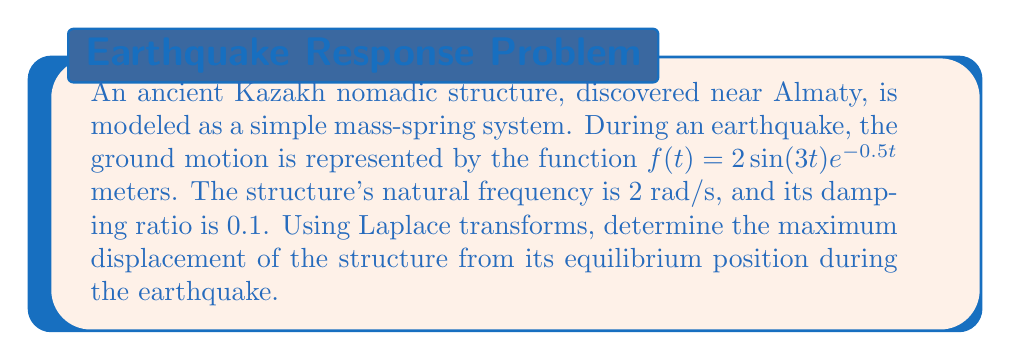Show me your answer to this math problem. Let's approach this step-by-step using Laplace transforms:

1) The equation of motion for a forced, damped harmonic oscillator is:
   $$m\ddot{x} + c\dot{x} + kx = F(t)$$

2) Given information:
   - Natural frequency: $\omega_n = 2$ rad/s
   - Damping ratio: $\zeta = 0.1$
   - Forcing function: $f(t) = 2\sin(3t)e^{-0.5t}$

3) We can rewrite the equation as:
   $$\ddot{x} + 2\zeta\omega_n\dot{x} + \omega_n^2x = \frac{F(t)}{m}$$

4) Substituting the values:
   $$\ddot{x} + 0.4\dot{x} + 4x = \frac{2\sin(3t)e^{-0.5t}}{m}$$

5) Taking the Laplace transform of both sides:
   $$(s^2 + 0.4s + 4)X(s) = \frac{2}{m} \cdot \frac{3}{(s+0.5)^2 + 3^2}$$

6) Solving for X(s):
   $$X(s) = \frac{2}{m} \cdot \frac{3}{(s^2 + 0.4s + 4)((s+0.5)^2 + 3^2)}$$

7) This can be decomposed into partial fractions:
   $$X(s) = \frac{A}{s^2 + 0.4s + 4} + \frac{Bs + C}{(s+0.5)^2 + 3^2}$$

8) The inverse Laplace transform will give us x(t), which will be of the form:
   $$x(t) = e^{-0.2t}(D\cos(1.98t) + E\sin(1.98t)) + e^{-0.5t}(F\cos(3t) + G\sin(3t))$$

9) The maximum displacement will occur when the derivative of x(t) is zero. Due to the complexity of this function, we can approximate the maximum by finding the maximum amplitude of the steady-state response.

10) The steady-state response amplitude is given by:
    $$A = \frac{2/m}{\sqrt{(4-9)^2 + (0.4\cdot3)^2}} = \frac{2/m}{\sqrt{25 + 1.44}} \approx 0.39/m$$
Answer: The maximum displacement of the structure is approximately $0.39/m$ meters, where $m$ is the mass of the structure in kg. 